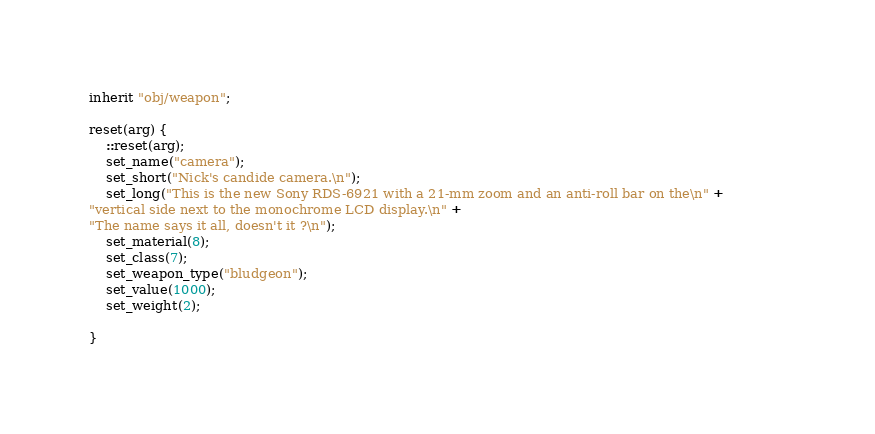<code> <loc_0><loc_0><loc_500><loc_500><_C_>inherit "obj/weapon"; 
 
reset(arg) {
    ::reset(arg);
    set_name("camera");
    set_short("Nick's candide camera.\n");
    set_long("This is the new Sony RDS-6921 with a 21-mm zoom and an anti-roll bar on the\n" +               
"vertical side next to the monochrome LCD display.\n" +
"The name says it all, doesn't it ?\n");
    set_material(8);
    set_class(7);
    set_weapon_type("bludgeon");
    set_value(1000);
    set_weight(2);
 
}

</code> 